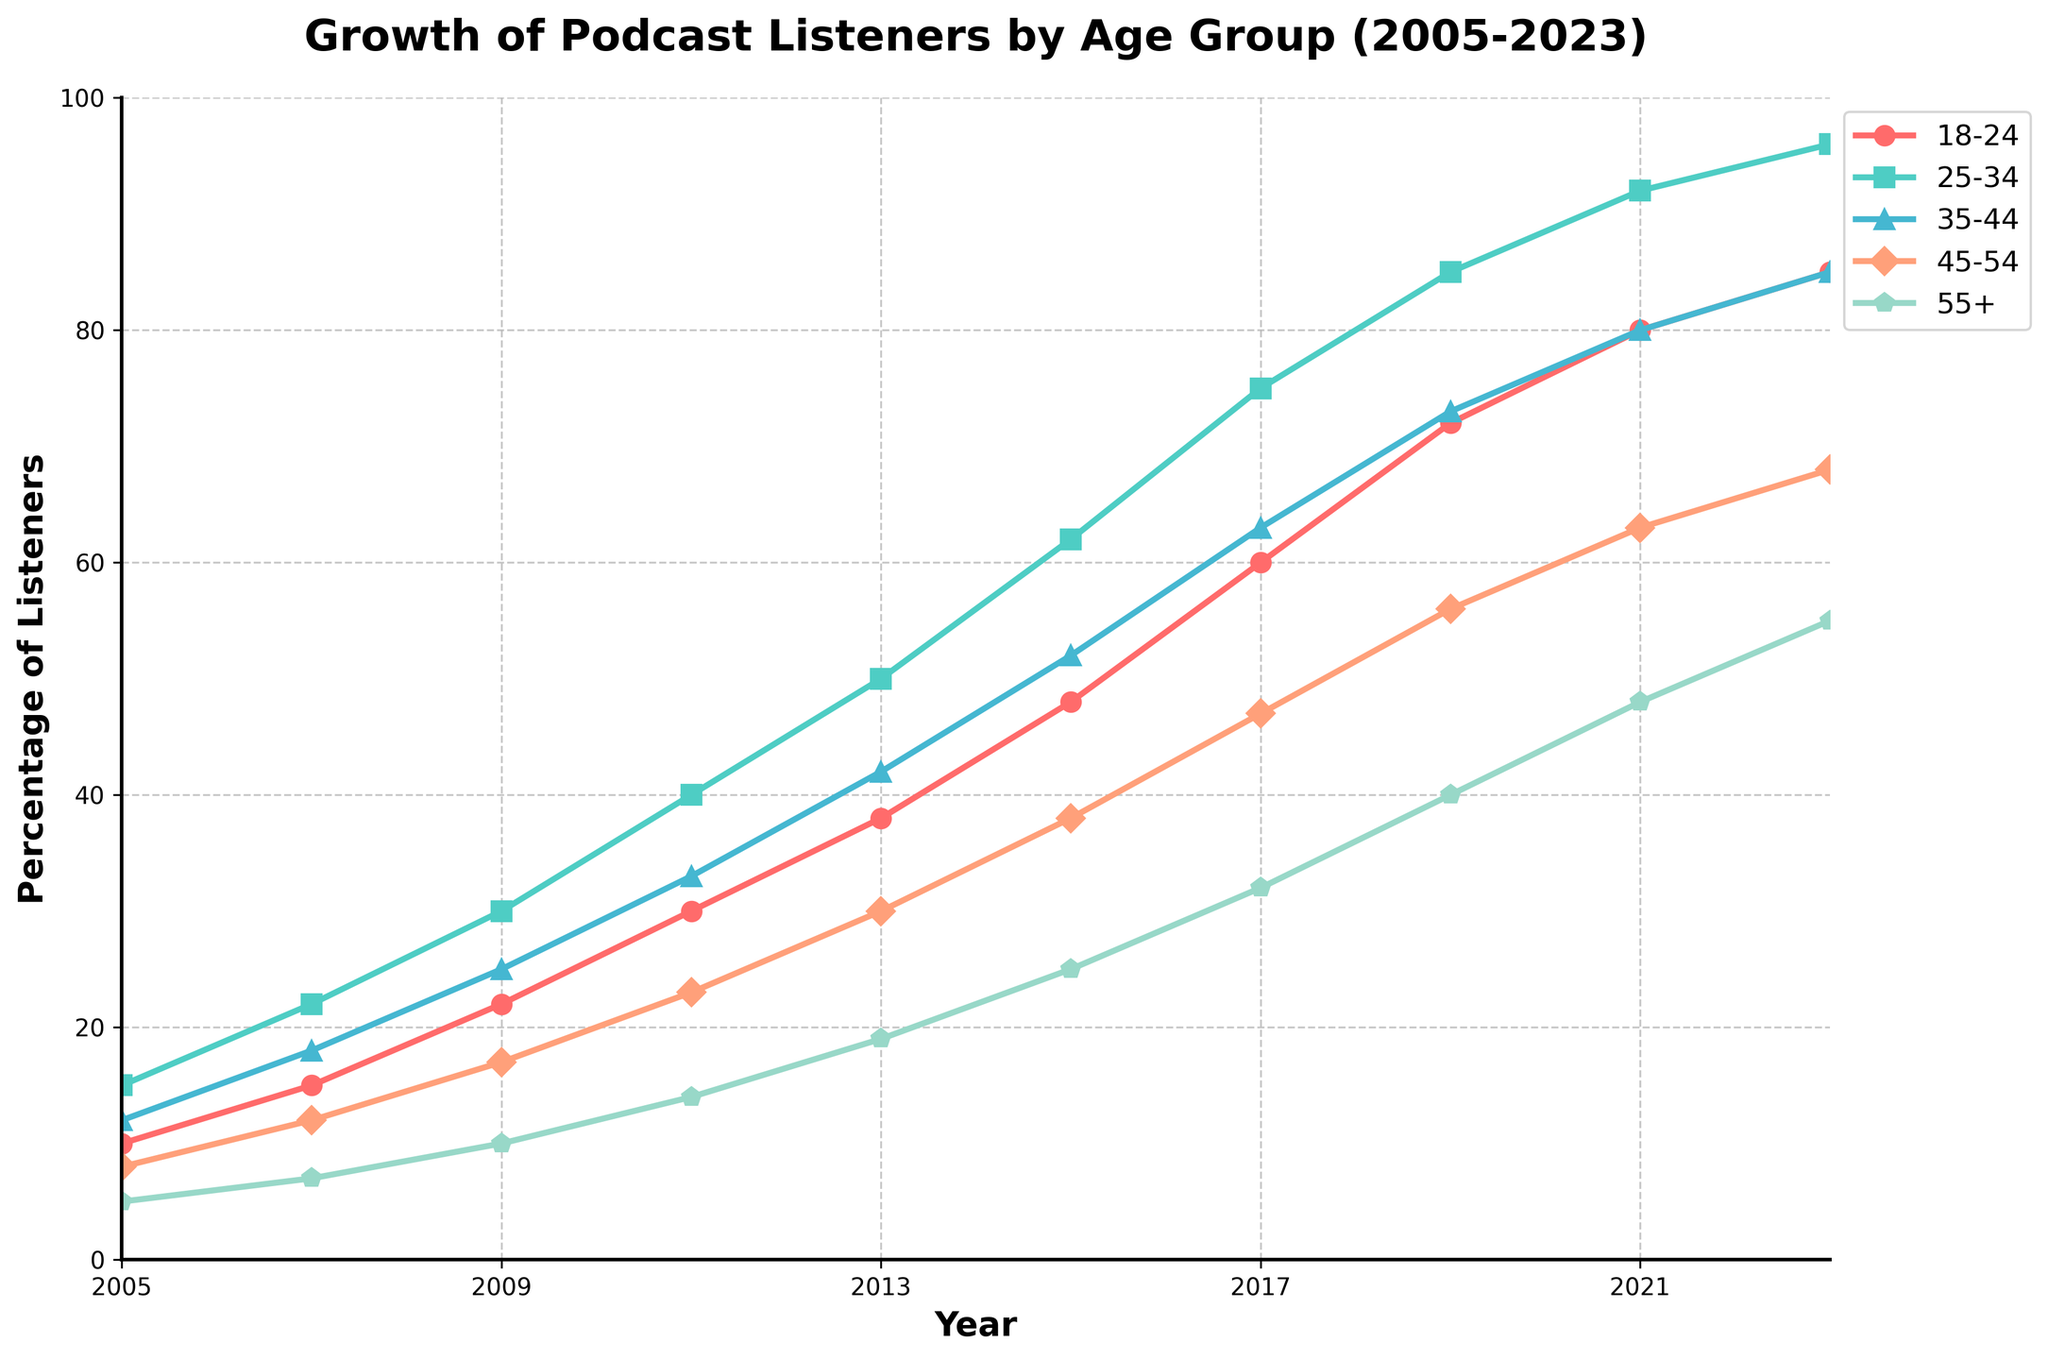What is the overall trend for the 25-34 age group from 2005 to 2023? The plot shows a consistently upward trend for the 25-34 age group, increasing from 15% in 2005 to 96% in 2023. This indicates a steady rise in podcast listeners in this age group over the years.
Answer: Steady upward trend Which age group had the highest percentage of listeners in 2023? To determine this, look at the values for 2023 in the chart and compare them. The 25-34 age group has the highest percentage at 96%.
Answer: 25-34 In what year did the 18-24 age group reach 60% of listeners? Locate the data points for the 18-24 age group and find the year corresponding to 60%. It happened in 2017.
Answer: 2017 How does the growth rate between 2005 and 2023 for the 55+ group compare to the 18-24 group? Comparing the initial and final values: For 55+, the increase is from 5% to 55%, a 50% increase. For 18-24, the increase is from 10% to 85%, a 75% increase. The 18-24 group has a higher growth rate.
Answer: 18-24 has a higher growth rate Which two age groups had the closest listener percentages in 2011? Check the 2011 values across all age groups and find those with the minimal difference. The 35-44 group (33%) and the 45-54 group (23%) are closest with a difference of 10%.
Answer: 35-44 and 45-54 What is the average percentage of listeners for the 35-44 age group across all years? Sum the percentages for the 35-44 age group across all years and divide by the number of years. (12 + 18 + 25 + 33 + 42 + 52 + 63 + 73 + 80 + 85) / 10 = 48.3%.
Answer: 48.3% What percentage increase did the 45-54 age group see from 2015 to 2021? Find the difference between the values for 2021 and 2015 for the 45-54 group, then divide by the 2015 value and multiply by 100: ((63 - 38) / 38) * 100 = 65.79%.
Answer: 65.79% How does the color used for the 18-24 age group help visually distinguish it from the other groups? The 18-24 age group uses a bright red color, which is visually striking and stands out against the more subtle shades used for other age groups. This helps quickly identify trends for this group.
Answer: Bright red color makes it distinct What are the percentages for the 55+ group in 2005 and in 2023, and how much have they changed? Check the values for the 55+ group in 2005 (5%) and 2023 (55%). The change is 55% - 5% = 50 percentage points.
Answer: Changed by 50 percentage points By how much did the percentage of listeners for the 25-34 age group increase from 2017 to 2019? Find the values for 2017 (75%) and 2019 (85%) for the 25-34 age group and calculate the difference: 85% - 75% = 10%.
Answer: 10% 